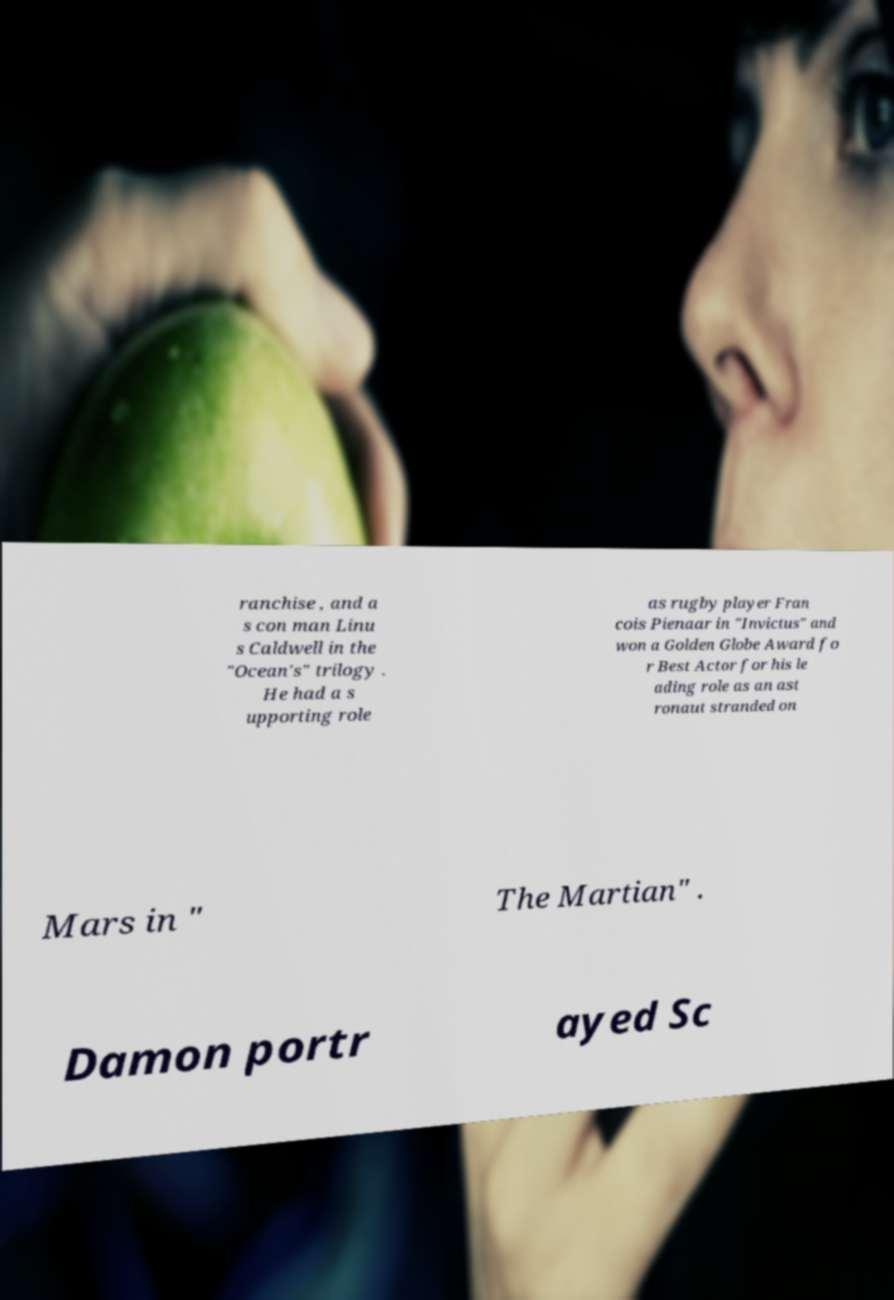Please read and relay the text visible in this image. What does it say? ranchise , and a s con man Linu s Caldwell in the "Ocean's" trilogy . He had a s upporting role as rugby player Fran cois Pienaar in "Invictus" and won a Golden Globe Award fo r Best Actor for his le ading role as an ast ronaut stranded on Mars in " The Martian" . Damon portr ayed Sc 